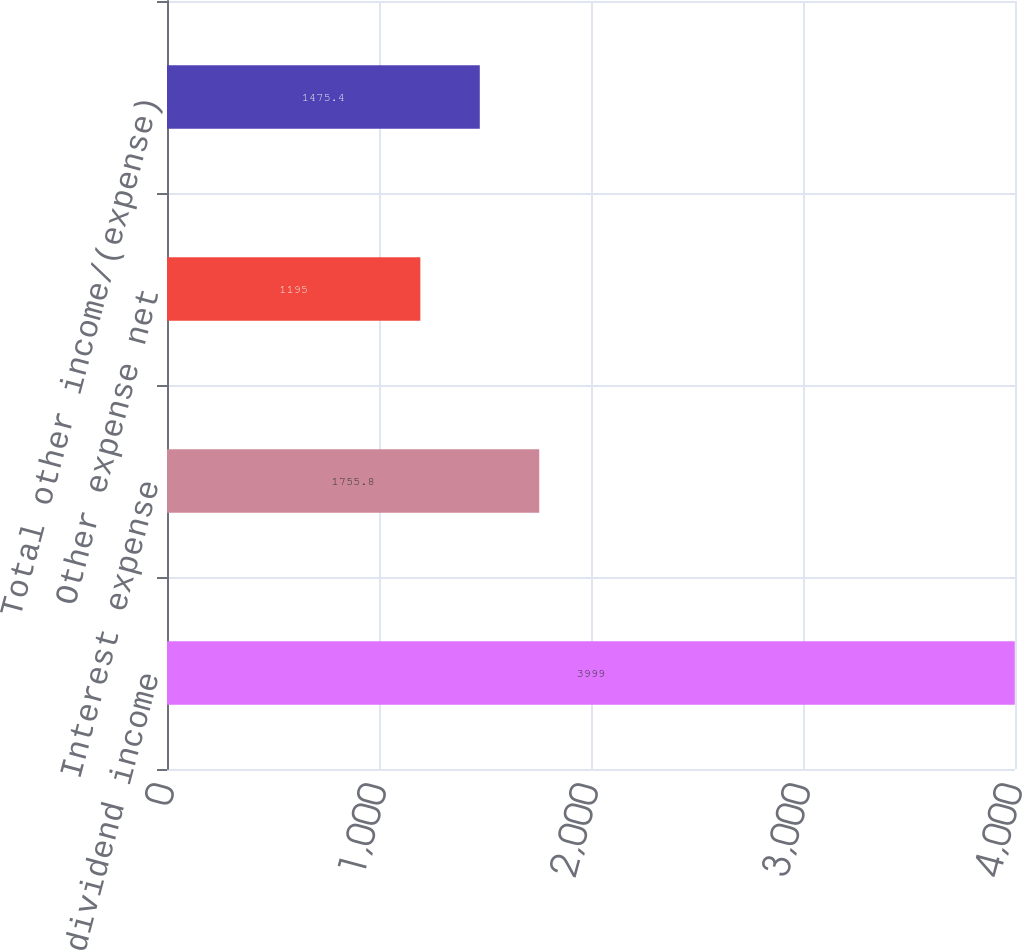Convert chart. <chart><loc_0><loc_0><loc_500><loc_500><bar_chart><fcel>Interest and dividend income<fcel>Interest expense<fcel>Other expense net<fcel>Total other income/(expense)<nl><fcel>3999<fcel>1755.8<fcel>1195<fcel>1475.4<nl></chart> 